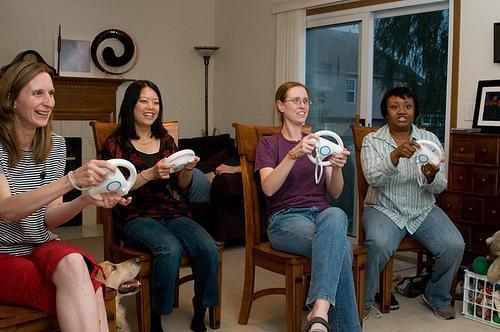How many people are playing the Wii?
Give a very brief answer. 4. How many people are reading books?
Give a very brief answer. 0. How many people are visible?
Give a very brief answer. 4. How many chairs are there?
Give a very brief answer. 3. How many donuts are the in the plate?
Give a very brief answer. 0. 